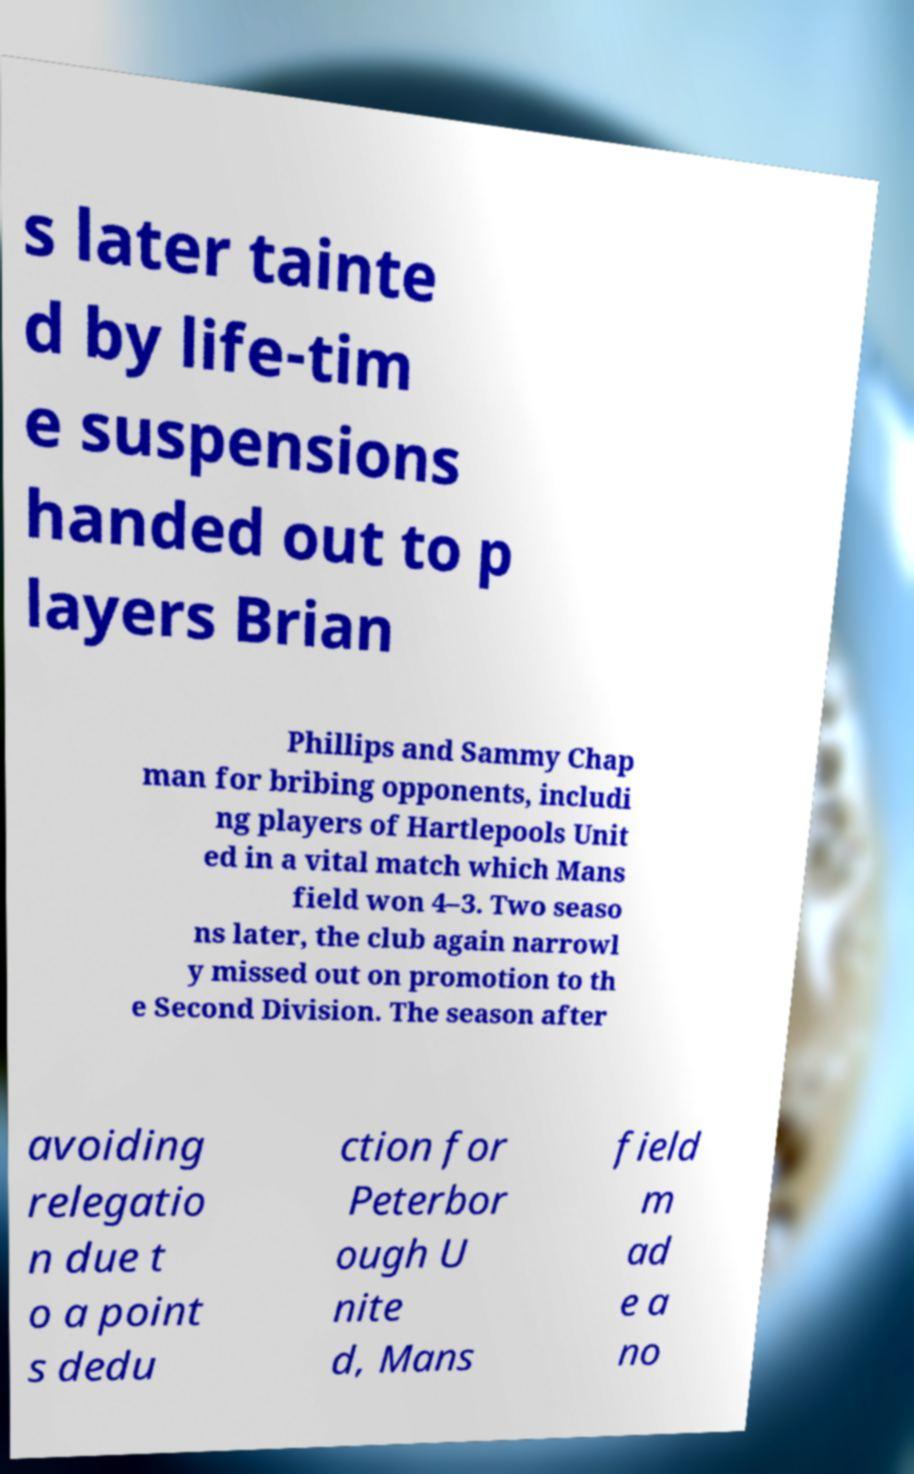For documentation purposes, I need the text within this image transcribed. Could you provide that? s later tainte d by life-tim e suspensions handed out to p layers Brian Phillips and Sammy Chap man for bribing opponents, includi ng players of Hartlepools Unit ed in a vital match which Mans field won 4–3. Two seaso ns later, the club again narrowl y missed out on promotion to th e Second Division. The season after avoiding relegatio n due t o a point s dedu ction for Peterbor ough U nite d, Mans field m ad e a no 